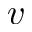Convert formula to latex. <formula><loc_0><loc_0><loc_500><loc_500>v</formula> 